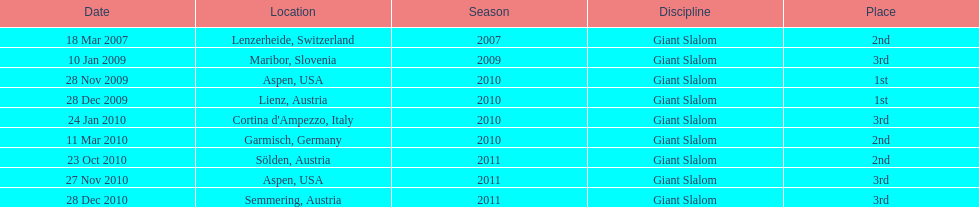Parse the table in full. {'header': ['Date', 'Location', 'Season', 'Discipline', 'Place'], 'rows': [['18 Mar 2007', 'Lenzerheide, Switzerland', '2007', 'Giant Slalom', '2nd'], ['10 Jan 2009', 'Maribor, Slovenia', '2009', 'Giant Slalom', '3rd'], ['28 Nov 2009', 'Aspen, USA', '2010', 'Giant Slalom', '1st'], ['28 Dec 2009', 'Lienz, Austria', '2010', 'Giant Slalom', '1st'], ['24 Jan 2010', "Cortina d'Ampezzo, Italy", '2010', 'Giant Slalom', '3rd'], ['11 Mar 2010', 'Garmisch, Germany', '2010', 'Giant Slalom', '2nd'], ['23 Oct 2010', 'Sölden, Austria', '2011', 'Giant Slalom', '2nd'], ['27 Nov 2010', 'Aspen, USA', '2011', 'Giant Slalom', '3rd'], ['28 Dec 2010', 'Semmering, Austria', '2011', 'Giant Slalom', '3rd']]} What was the finishing place of the last race in december 2010? 3rd. 